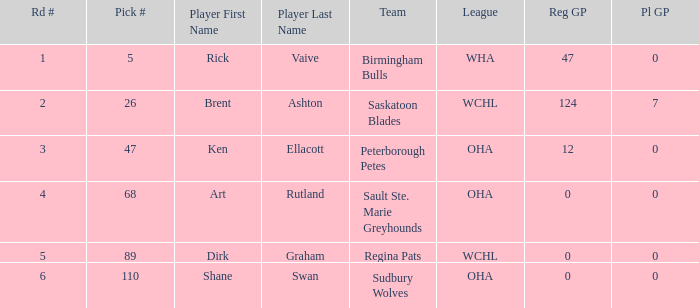How many reg GP for rick vaive in round 1? None. 